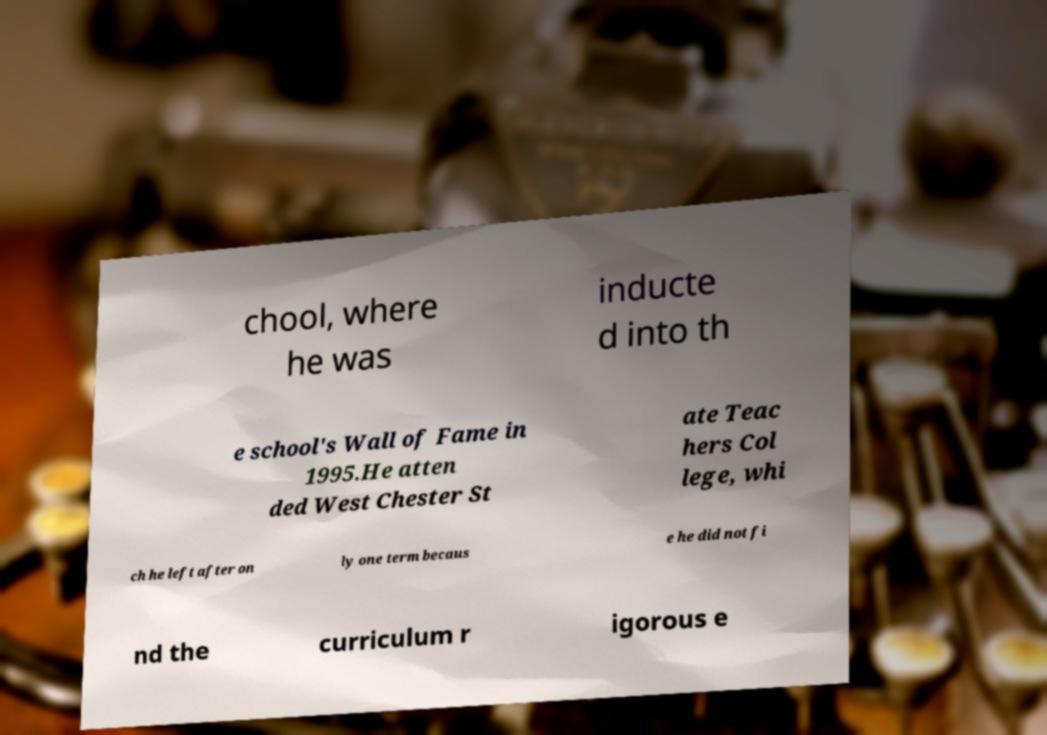What messages or text are displayed in this image? I need them in a readable, typed format. chool, where he was inducte d into th e school's Wall of Fame in 1995.He atten ded West Chester St ate Teac hers Col lege, whi ch he left after on ly one term becaus e he did not fi nd the curriculum r igorous e 